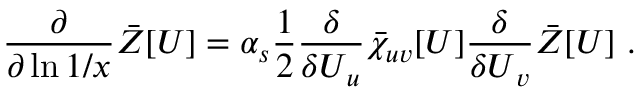Convert formula to latex. <formula><loc_0><loc_0><loc_500><loc_500>\frac { \partial } { \partial \ln 1 / x } \ B a r Z [ U ] = \alpha _ { s } \frac { 1 } { 2 } \frac { \delta } { \delta U _ { u } } \ B a r \chi _ { u v } [ U ] \frac { \delta } { \delta U _ { v } } \ B a r Z [ U ] \ .</formula> 